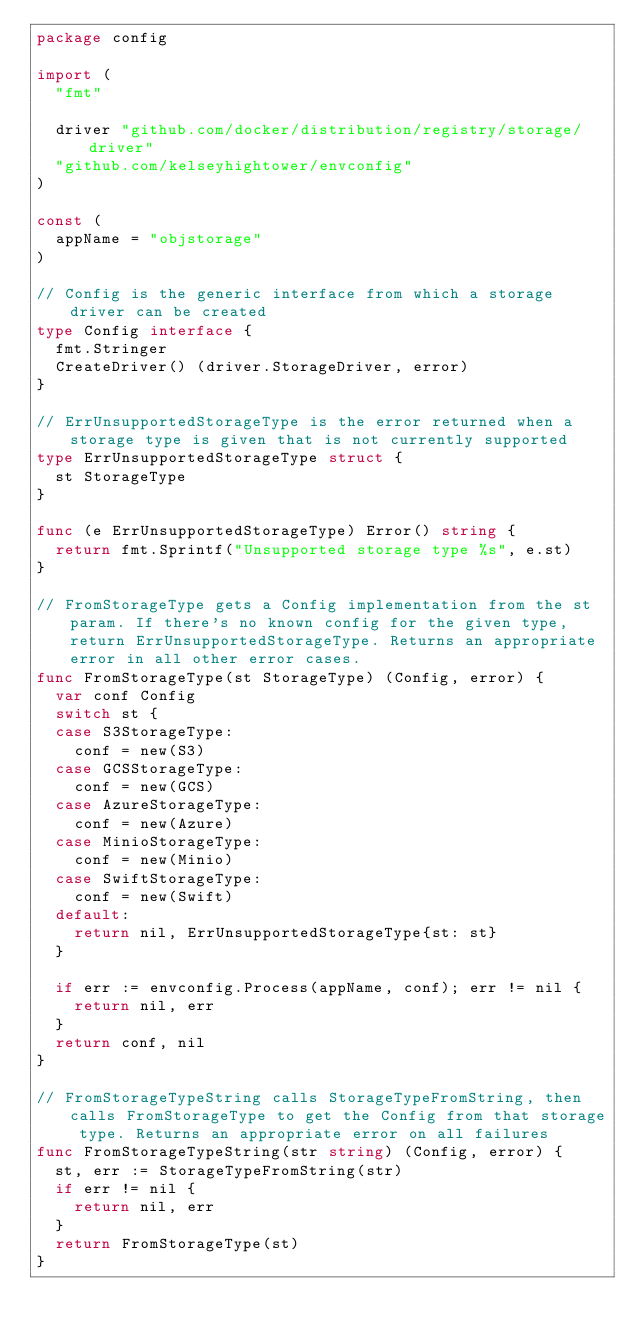<code> <loc_0><loc_0><loc_500><loc_500><_Go_>package config

import (
	"fmt"

	driver "github.com/docker/distribution/registry/storage/driver"
	"github.com/kelseyhightower/envconfig"
)

const (
	appName = "objstorage"
)

// Config is the generic interface from which a storage driver can be created
type Config interface {
	fmt.Stringer
	CreateDriver() (driver.StorageDriver, error)
}

// ErrUnsupportedStorageType is the error returned when a storage type is given that is not currently supported
type ErrUnsupportedStorageType struct {
	st StorageType
}

func (e ErrUnsupportedStorageType) Error() string {
	return fmt.Sprintf("Unsupported storage type %s", e.st)
}

// FromStorageType gets a Config implementation from the st param. If there's no known config for the given type, return ErrUnsupportedStorageType. Returns an appropriate error in all other error cases.
func FromStorageType(st StorageType) (Config, error) {
	var conf Config
	switch st {
	case S3StorageType:
		conf = new(S3)
	case GCSStorageType:
		conf = new(GCS)
	case AzureStorageType:
		conf = new(Azure)
	case MinioStorageType:
		conf = new(Minio)
	case SwiftStorageType:
		conf = new(Swift)
	default:
		return nil, ErrUnsupportedStorageType{st: st}
	}

	if err := envconfig.Process(appName, conf); err != nil {
		return nil, err
	}
	return conf, nil
}

// FromStorageTypeString calls StorageTypeFromString, then calls FromStorageType to get the Config from that storage type. Returns an appropriate error on all failures
func FromStorageTypeString(str string) (Config, error) {
	st, err := StorageTypeFromString(str)
	if err != nil {
		return nil, err
	}
	return FromStorageType(st)
}
</code> 